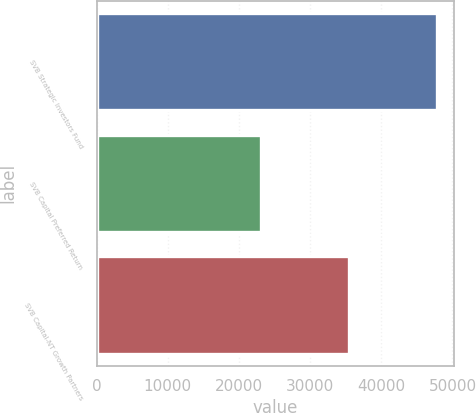<chart> <loc_0><loc_0><loc_500><loc_500><bar_chart><fcel>SVB Strategic Investors Fund<fcel>SVB Capital Preferred Return<fcel>SVB Capital-NT Growth Partners<nl><fcel>47779.4<fcel>23071<fcel>35425.2<nl></chart> 